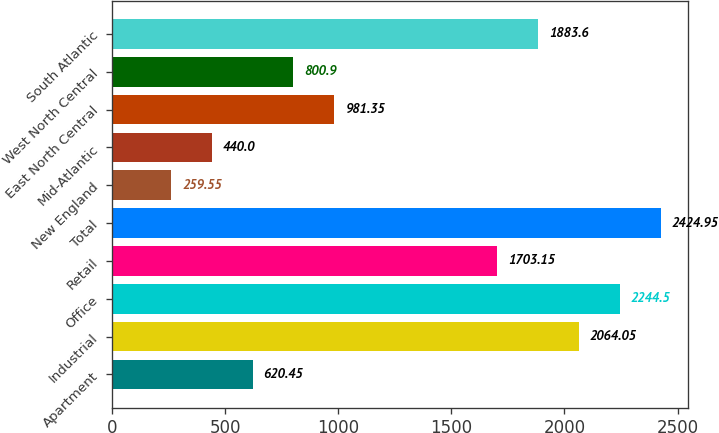Convert chart to OTSL. <chart><loc_0><loc_0><loc_500><loc_500><bar_chart><fcel>Apartment<fcel>Industrial<fcel>Office<fcel>Retail<fcel>Total<fcel>New England<fcel>Mid-Atlantic<fcel>East North Central<fcel>West North Central<fcel>South Atlantic<nl><fcel>620.45<fcel>2064.05<fcel>2244.5<fcel>1703.15<fcel>2424.95<fcel>259.55<fcel>440<fcel>981.35<fcel>800.9<fcel>1883.6<nl></chart> 